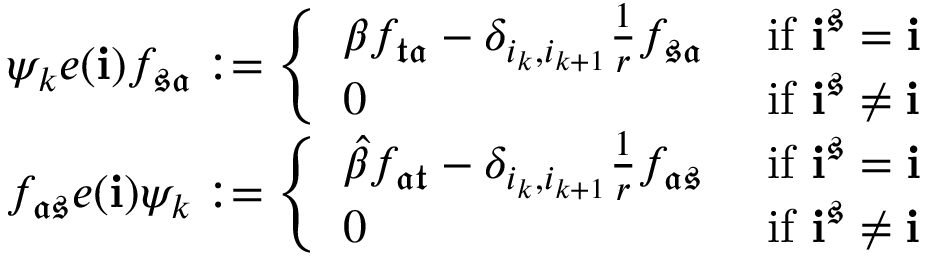<formula> <loc_0><loc_0><loc_500><loc_500>\begin{array} { r l } & { \psi _ { k } e ( i ) f _ { \mathfrak { s } \mathfrak { a } } \colon = \left \{ \begin{array} { l l } { \beta f _ { \mathfrak { t } \mathfrak { a } } - \delta _ { i _ { k } , i _ { k + 1 } } \frac { 1 } { r } f _ { \mathfrak { s } \mathfrak { a } } } & { i f i ^ { \mathfrak { s } } = i } \\ { 0 } & { i f i ^ { \mathfrak { s } } \neq i } \end{array} } \\ & { f _ { \mathfrak { a } \mathfrak { s } } e ( i ) \psi _ { k } \colon = \left \{ \begin{array} { l l } { \widehat { \beta } f _ { \mathfrak { a } \mathfrak { t } } - \delta _ { i _ { k } , i _ { k + 1 } } \frac { 1 } { r } f _ { \mathfrak { a } \mathfrak { s } } } & { i f i ^ { \mathfrak { s } } = i } \\ { 0 } & { i f i ^ { \mathfrak { s } } \neq i } \end{array} } \end{array}</formula> 